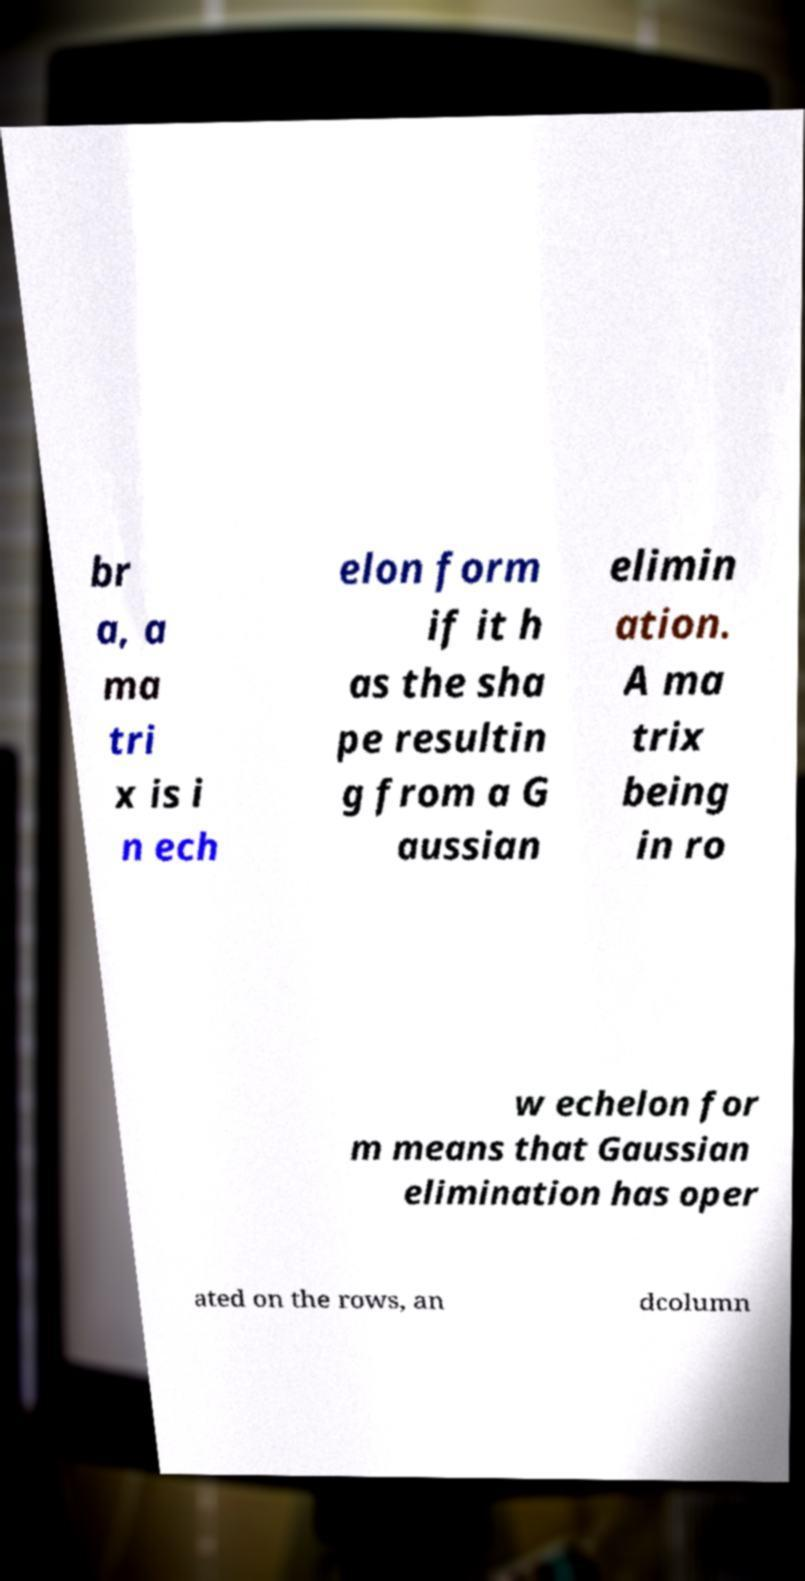Could you assist in decoding the text presented in this image and type it out clearly? br a, a ma tri x is i n ech elon form if it h as the sha pe resultin g from a G aussian elimin ation. A ma trix being in ro w echelon for m means that Gaussian elimination has oper ated on the rows, an dcolumn 